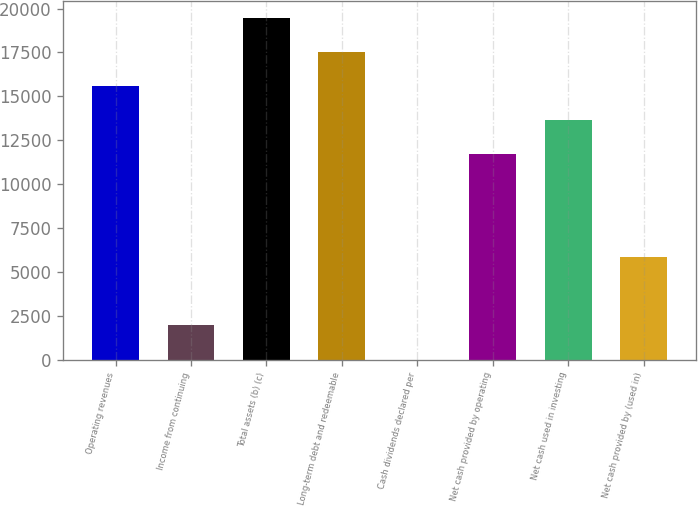Convert chart to OTSL. <chart><loc_0><loc_0><loc_500><loc_500><bar_chart><fcel>Operating revenues<fcel>Income from continuing<fcel>Total assets (b) (c)<fcel>Long-term debt and redeemable<fcel>Cash dividends declared per<fcel>Net cash provided by operating<fcel>Net cash used in investing<fcel>Net cash provided by (used in)<nl><fcel>15585.9<fcel>1949.69<fcel>19482<fcel>17533.9<fcel>1.66<fcel>11689.8<fcel>13637.9<fcel>5845.75<nl></chart> 